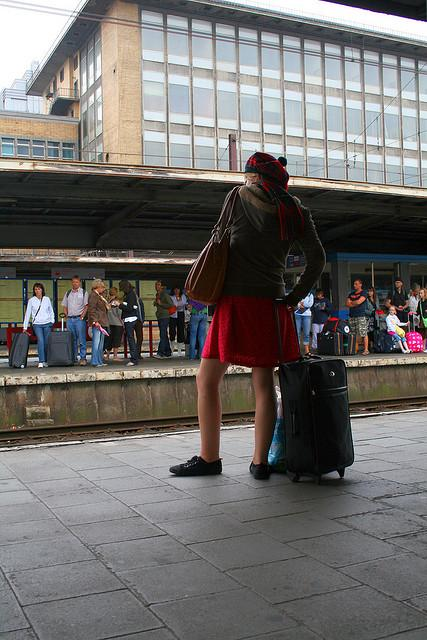What color is the suitcase held by the girl on the other side of the boarding deck to the right of the woman in the foreground? black 